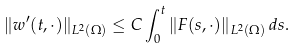Convert formula to latex. <formula><loc_0><loc_0><loc_500><loc_500>\| w ^ { \prime } ( t , \cdot ) \| _ { L ^ { 2 } ( \Omega ) } \leq C \int _ { 0 } ^ { t } \| F ( s , \cdot ) \| _ { L ^ { 2 } ( \Omega ) } \, d s .</formula> 